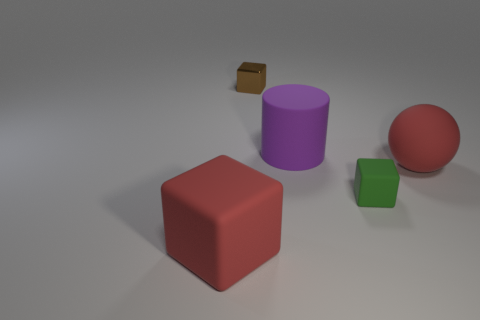What's the texture of the objects in this scene? The objects appear to have different textures. The red ball looks smooth and shiny, suggesting it's quite bouncy. The purple cylinder and green cube seem to have a slightly matte finish, possibly made of plastic or wood, while the brown box looks like it has a rougher, cardboard-like texture. Could you guess the purpose or use of these objects? Certainly! The red rubber ball could be for playing catch or other recreational activities. The purple cylinder and green cube might be part of a children's toy set, designed to teach shapes and colors. The small brown box could be packaging for a product or used simply for storage. 